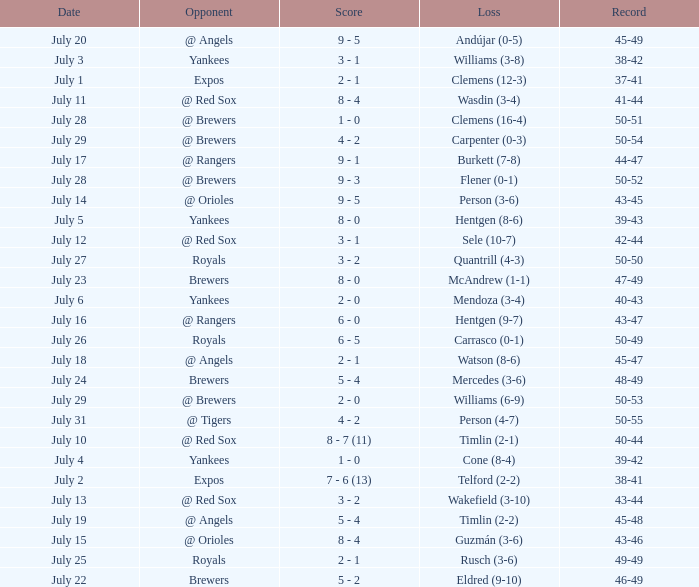What's the record on july 10? 40-44. 